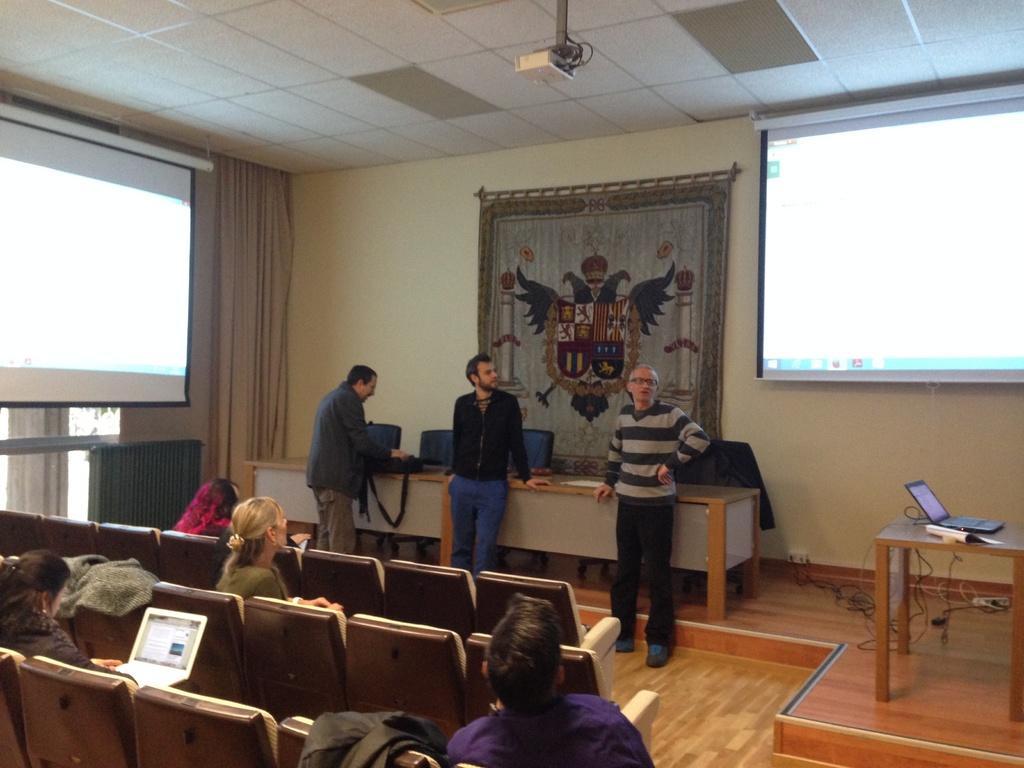Please provide a concise description of this image. In this image i can see few people sitting and few people standing. In the background i can see the wall, a curtain, 2 screens, a cloth, the ceiling and a projector. 